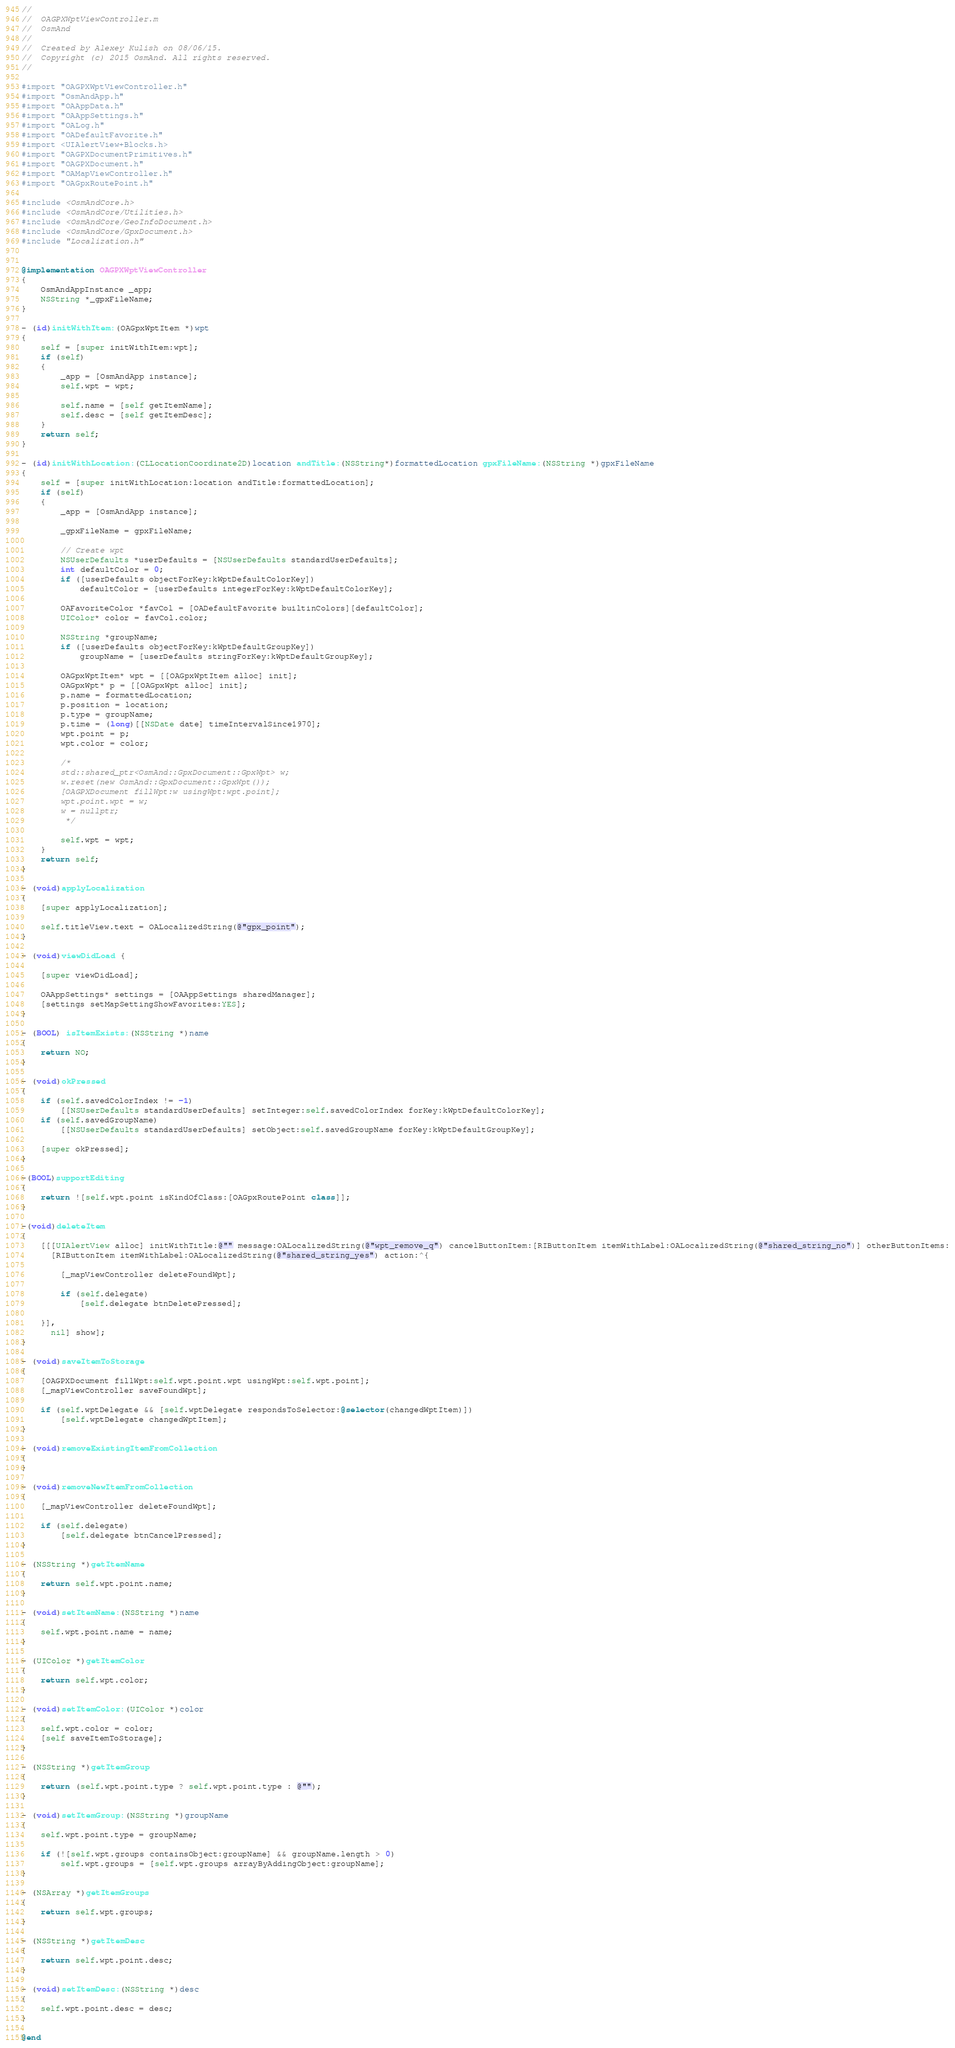Convert code to text. <code><loc_0><loc_0><loc_500><loc_500><_ObjectiveC_>//
//  OAGPXWptViewController.m
//  OsmAnd
//
//  Created by Alexey Kulish on 08/06/15.
//  Copyright (c) 2015 OsmAnd. All rights reserved.
//

#import "OAGPXWptViewController.h"
#import "OsmAndApp.h"
#import "OAAppData.h"
#import "OAAppSettings.h"
#import "OALog.h"
#import "OADefaultFavorite.h"
#import <UIAlertView+Blocks.h>
#import "OAGPXDocumentPrimitives.h"
#import "OAGPXDocument.h"
#import "OAMapViewController.h"
#import "OAGpxRoutePoint.h"

#include <OsmAndCore.h>
#include <OsmAndCore/Utilities.h>
#include <OsmAndCore/GeoInfoDocument.h>
#include <OsmAndCore/GpxDocument.h>
#include "Localization.h"


@implementation OAGPXWptViewController
{
    OsmAndAppInstance _app;
    NSString *_gpxFileName;
}

- (id)initWithItem:(OAGpxWptItem *)wpt
{
    self = [super initWithItem:wpt];
    if (self)
    {
        _app = [OsmAndApp instance];
        self.wpt = wpt;
        
        self.name = [self getItemName];
        self.desc = [self getItemDesc];
    }
    return self;
}

- (id)initWithLocation:(CLLocationCoordinate2D)location andTitle:(NSString*)formattedLocation gpxFileName:(NSString *)gpxFileName
{
    self = [super initWithLocation:location andTitle:formattedLocation];
    if (self)
    {
        _app = [OsmAndApp instance];
        
        _gpxFileName = gpxFileName;
        
        // Create wpt
        NSUserDefaults *userDefaults = [NSUserDefaults standardUserDefaults];
        int defaultColor = 0;
        if ([userDefaults objectForKey:kWptDefaultColorKey])
            defaultColor = [userDefaults integerForKey:kWptDefaultColorKey];
        
        OAFavoriteColor *favCol = [OADefaultFavorite builtinColors][defaultColor];
        UIColor* color = favCol.color;

        NSString *groupName;
        if ([userDefaults objectForKey:kWptDefaultGroupKey])
            groupName = [userDefaults stringForKey:kWptDefaultGroupKey];
        
        OAGpxWptItem* wpt = [[OAGpxWptItem alloc] init];
        OAGpxWpt* p = [[OAGpxWpt alloc] init];
        p.name = formattedLocation;
        p.position = location;
        p.type = groupName;
        p.time = (long)[[NSDate date] timeIntervalSince1970];
        wpt.point = p;
        wpt.color = color;

        /*
        std::shared_ptr<OsmAnd::GpxDocument::GpxWpt> w;
        w.reset(new OsmAnd::GpxDocument::GpxWpt());
        [OAGPXDocument fillWpt:w usingWpt:wpt.point];
        wpt.point.wpt = w;
        w = nullptr;
         */
        
        self.wpt = wpt;
    }
    return self;
}

- (void)applyLocalization
{
    [super applyLocalization];
    
    self.titleView.text = OALocalizedString(@"gpx_point");
}

- (void)viewDidLoad {
    
    [super viewDidLoad];
    
    OAAppSettings* settings = [OAAppSettings sharedManager];
    [settings setMapSettingShowFavorites:YES];
}

- (BOOL) isItemExists:(NSString *)name
{
    return NO;
}

- (void)okPressed
{
    if (self.savedColorIndex != -1)
        [[NSUserDefaults standardUserDefaults] setInteger:self.savedColorIndex forKey:kWptDefaultColorKey];
    if (self.savedGroupName)
        [[NSUserDefaults standardUserDefaults] setObject:self.savedGroupName forKey:kWptDefaultGroupKey];
    
    [super okPressed];
}

-(BOOL)supportEditing
{
    return ![self.wpt.point isKindOfClass:[OAGpxRoutePoint class]];
}

-(void)deleteItem
{
    [[[UIAlertView alloc] initWithTitle:@"" message:OALocalizedString(@"wpt_remove_q") cancelButtonItem:[RIButtonItem itemWithLabel:OALocalizedString(@"shared_string_no")] otherButtonItems:
      [RIButtonItem itemWithLabel:OALocalizedString(@"shared_string_yes") action:^{
        
        [_mapViewController deleteFoundWpt];
        
        if (self.delegate)
            [self.delegate btnDeletePressed];

    }],
      nil] show];
}

- (void)saveItemToStorage
{
    [OAGPXDocument fillWpt:self.wpt.point.wpt usingWpt:self.wpt.point];
    [_mapViewController saveFoundWpt];
    
    if (self.wptDelegate && [self.wptDelegate respondsToSelector:@selector(changedWptItem)])
        [self.wptDelegate changedWptItem];
}

- (void)removeExistingItemFromCollection
{
}

- (void)removeNewItemFromCollection
{
    [_mapViewController deleteFoundWpt];
    
    if (self.delegate)
        [self.delegate btnCancelPressed];
}

- (NSString *)getItemName
{
    return self.wpt.point.name;
}

- (void)setItemName:(NSString *)name
{
    self.wpt.point.name = name;
}

- (UIColor *)getItemColor
{
    return self.wpt.color;
}

- (void)setItemColor:(UIColor *)color
{
    self.wpt.color = color;
    [self saveItemToStorage];
}

- (NSString *)getItemGroup
{
    return (self.wpt.point.type ? self.wpt.point.type : @"");
}

- (void)setItemGroup:(NSString *)groupName
{
    self.wpt.point.type = groupName;
    
    if (![self.wpt.groups containsObject:groupName] && groupName.length > 0)
        self.wpt.groups = [self.wpt.groups arrayByAddingObject:groupName];
}

- (NSArray *)getItemGroups
{
    return self.wpt.groups;
}

- (NSString *)getItemDesc
{
    return self.wpt.point.desc;
}

- (void)setItemDesc:(NSString *)desc
{
    self.wpt.point.desc = desc;
}

@end
</code> 